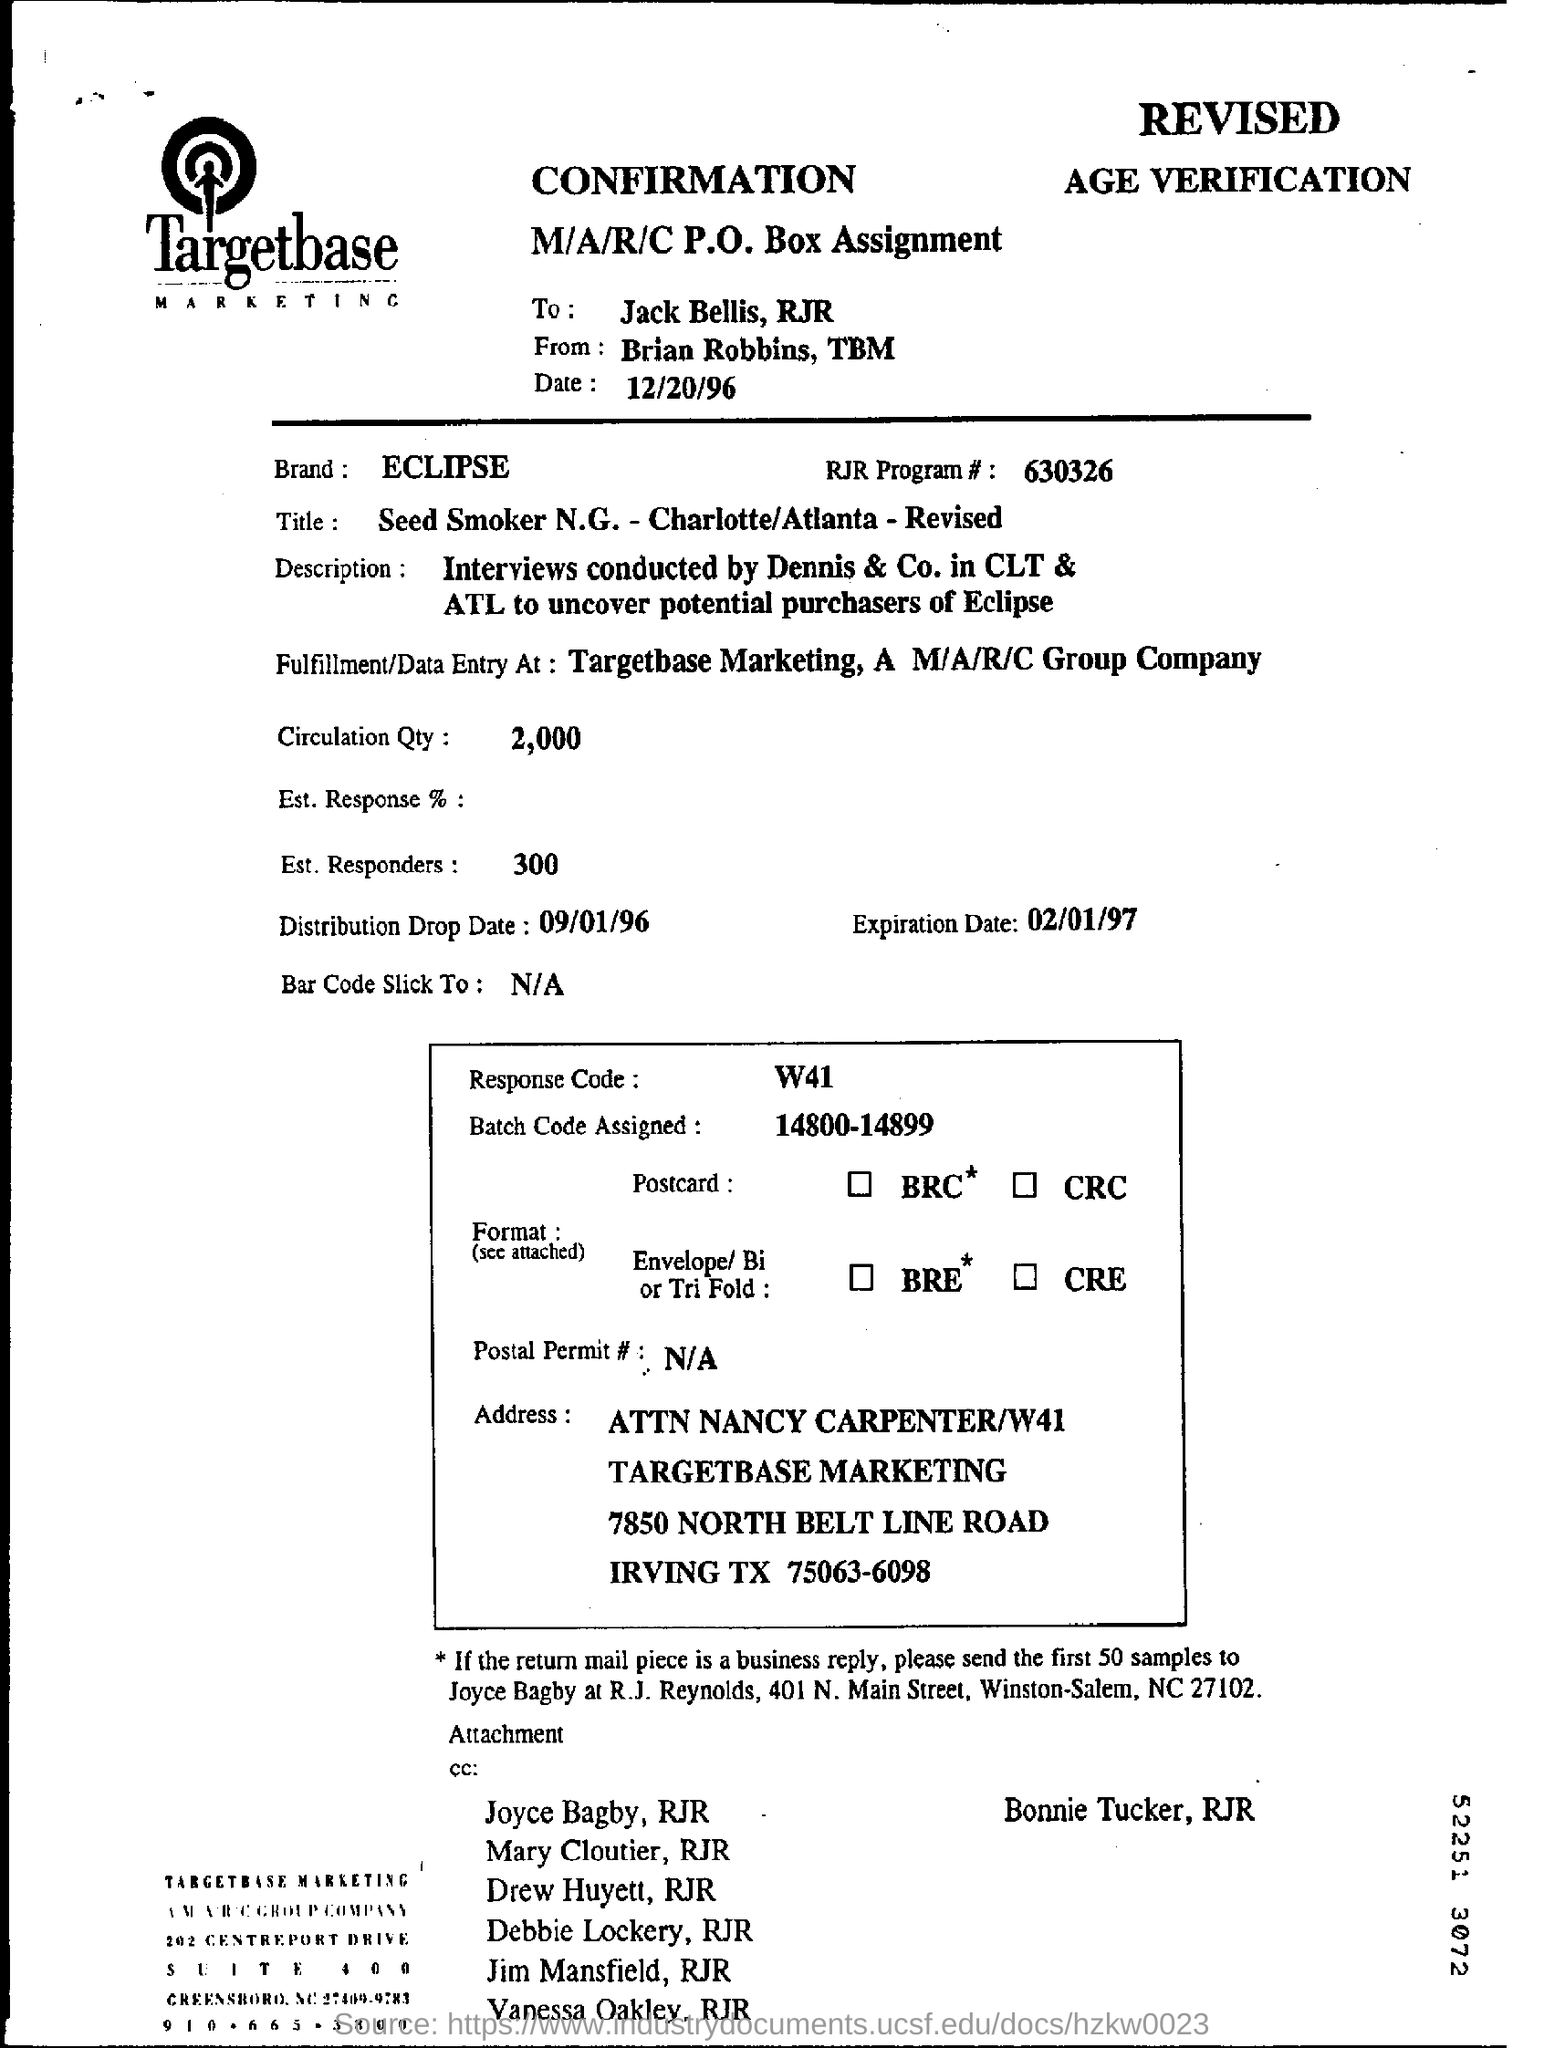Who is the sender of the confirmation from targetbase?
Provide a succinct answer. Brian Robbins. What is the name of the brand ?
Make the answer very short. Eclipse. What is the rjr program#?
Keep it short and to the point. 630326. What is the code of the response ?
Provide a succinct answer. W41. 